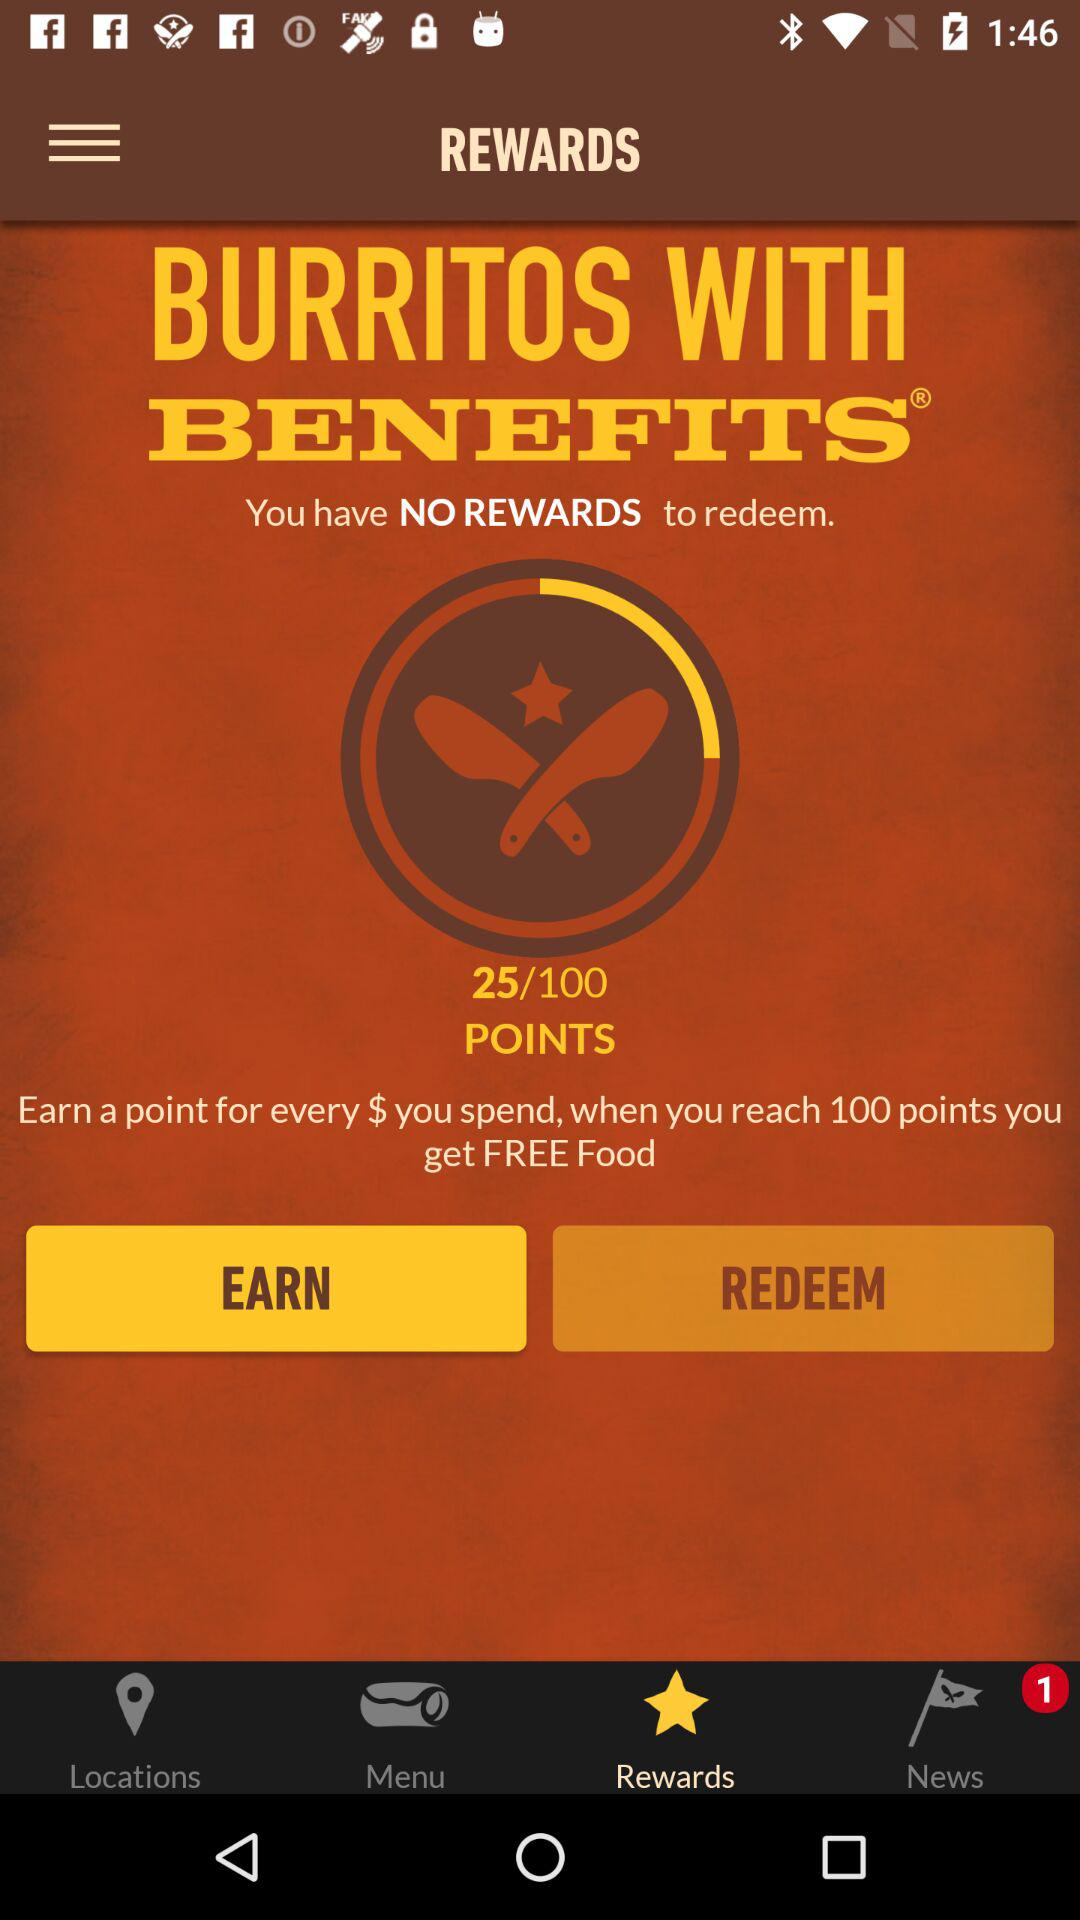How many points must be reached to get free food? To get free food, you must reach 100 points. 